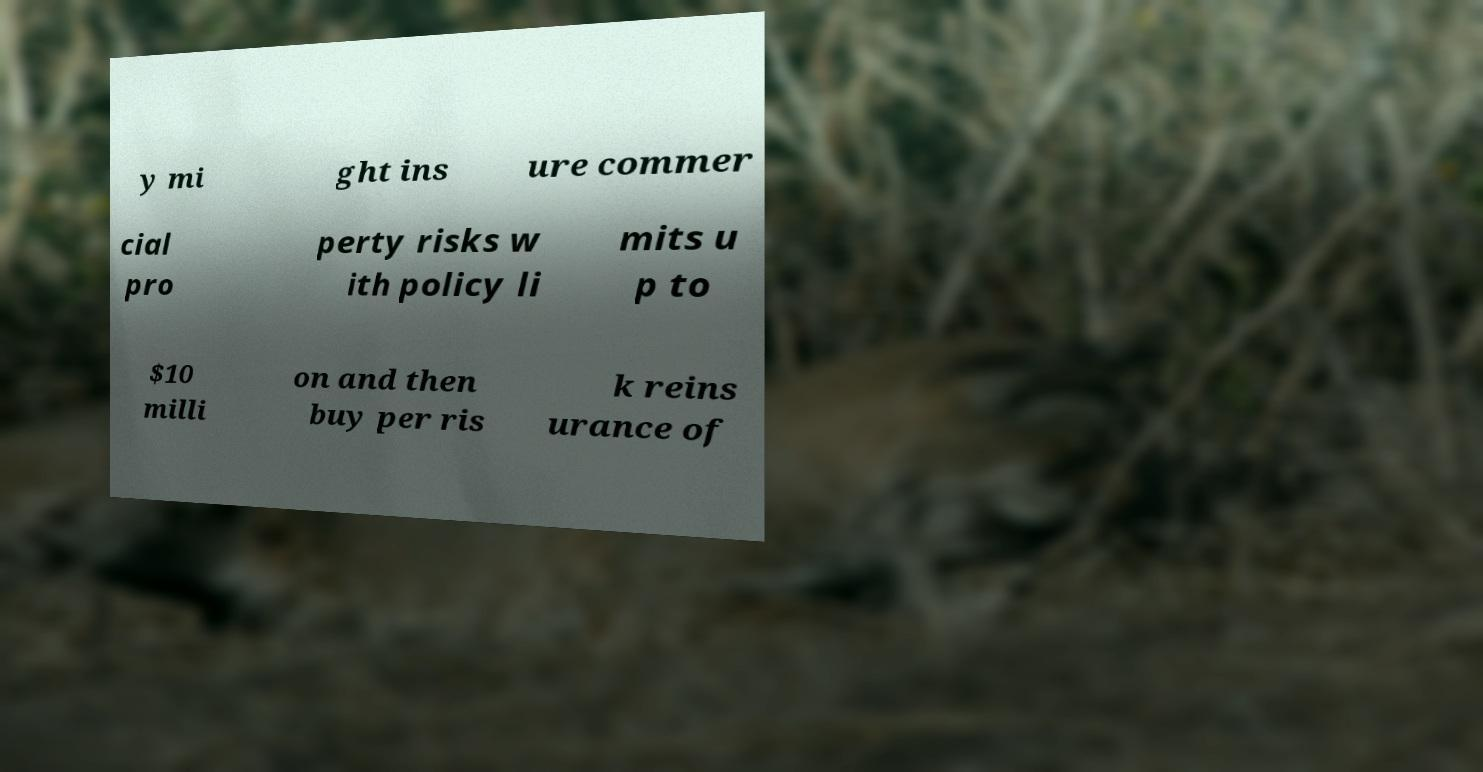Could you extract and type out the text from this image? y mi ght ins ure commer cial pro perty risks w ith policy li mits u p to $10 milli on and then buy per ris k reins urance of 